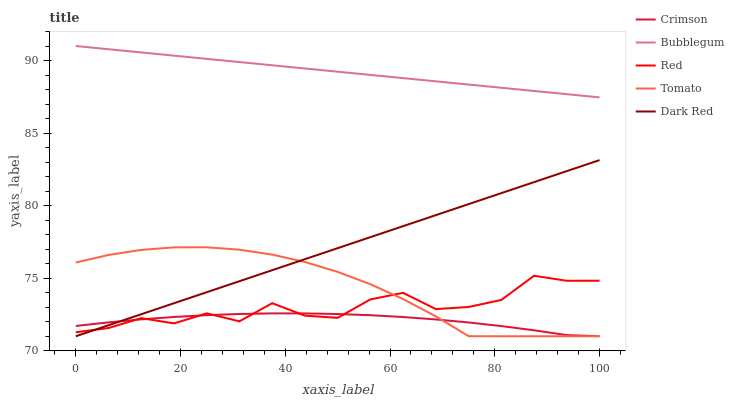Does Crimson have the minimum area under the curve?
Answer yes or no. Yes. Does Bubblegum have the maximum area under the curve?
Answer yes or no. Yes. Does Tomato have the minimum area under the curve?
Answer yes or no. No. Does Tomato have the maximum area under the curve?
Answer yes or no. No. Is Bubblegum the smoothest?
Answer yes or no. Yes. Is Red the roughest?
Answer yes or no. Yes. Is Tomato the smoothest?
Answer yes or no. No. Is Tomato the roughest?
Answer yes or no. No. Does Red have the lowest value?
Answer yes or no. No. Does Tomato have the highest value?
Answer yes or no. No. Is Crimson less than Bubblegum?
Answer yes or no. Yes. Is Bubblegum greater than Tomato?
Answer yes or no. Yes. Does Crimson intersect Bubblegum?
Answer yes or no. No. 